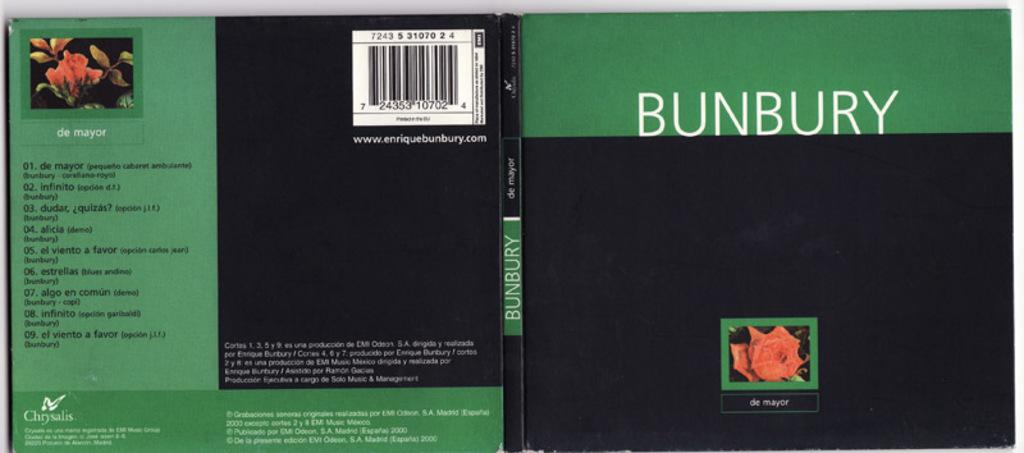What is written under the red rose?
Offer a very short reply. De mayor. 